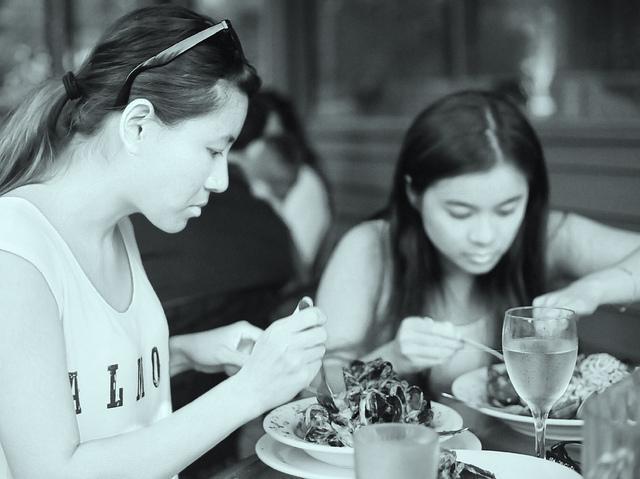How many bowls are there?
Give a very brief answer. 2. How many people are in the picture?
Give a very brief answer. 4. How many chairs are in the picture?
Give a very brief answer. 1. How many bears are standing near the waterfalls?
Give a very brief answer. 0. 